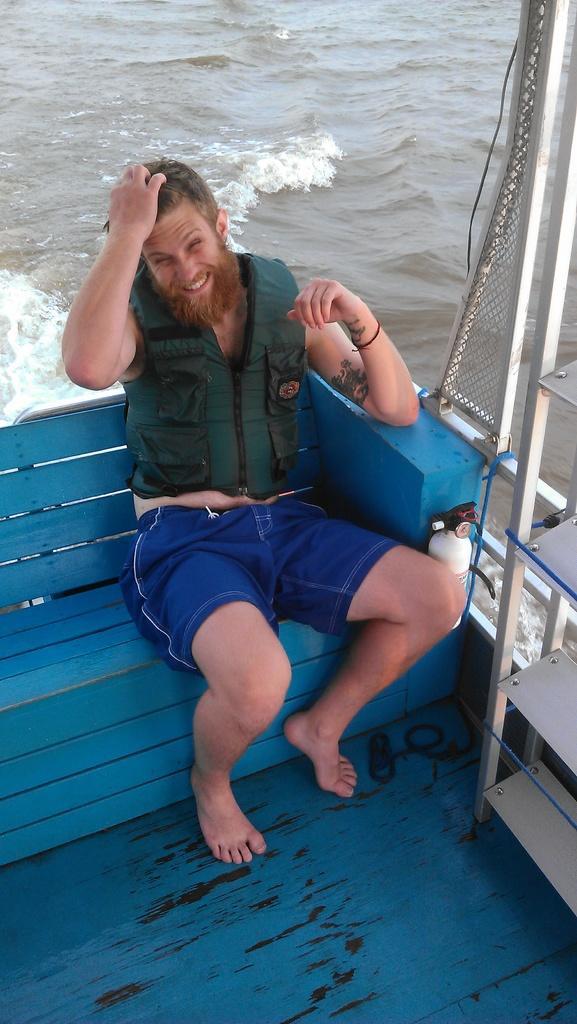Please provide a concise description of this image. In this image I can see the person sitting on the bench. The person is wearing green and blue color dress and the bench is in blue color, background I can see the water. 